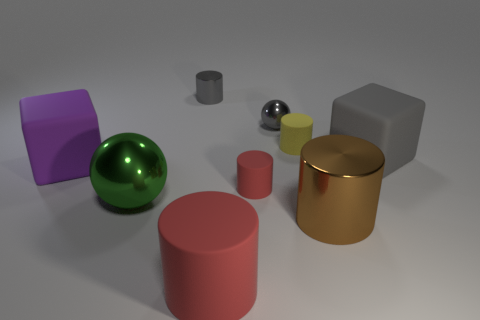Does the small sphere have the same color as the small shiny cylinder?
Offer a terse response. Yes. What material is the brown cylinder that is the same size as the green shiny thing?
Your response must be concise. Metal. Does the large brown cylinder have the same material as the yellow cylinder?
Your answer should be compact. No. How many small gray cylinders are made of the same material as the large gray cube?
Give a very brief answer. 0. How many things are either small matte cylinders that are in front of the big gray block or small matte cylinders to the left of the large metal cylinder?
Provide a succinct answer. 2. Is the number of small matte things behind the tiny red rubber cylinder greater than the number of large green shiny balls on the left side of the big green sphere?
Make the answer very short. Yes. What color is the large block in front of the large gray cube?
Your answer should be very brief. Purple. Is there another big object of the same shape as the gray rubber thing?
Keep it short and to the point. Yes. What number of brown things are either tiny spheres or metallic objects?
Give a very brief answer. 1. Are there any purple rubber objects of the same size as the brown shiny cylinder?
Keep it short and to the point. Yes. 